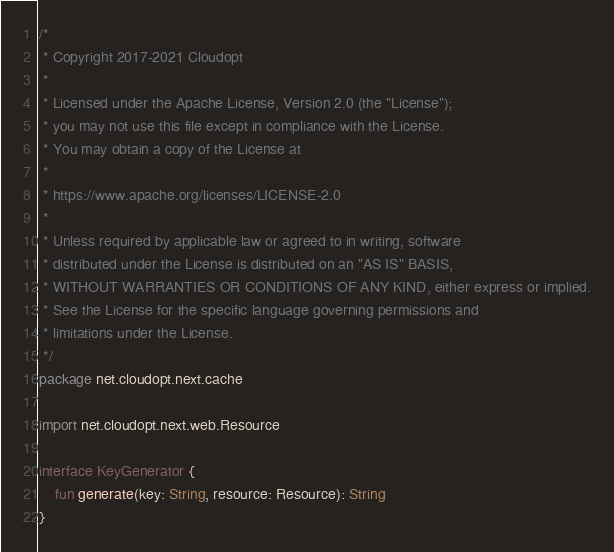Convert code to text. <code><loc_0><loc_0><loc_500><loc_500><_Kotlin_>/*
 * Copyright 2017-2021 Cloudopt
 *
 * Licensed under the Apache License, Version 2.0 (the "License");
 * you may not use this file except in compliance with the License.
 * You may obtain a copy of the License at
 *
 * https://www.apache.org/licenses/LICENSE-2.0
 *
 * Unless required by applicable law or agreed to in writing, software
 * distributed under the License is distributed on an "AS IS" BASIS,
 * WITHOUT WARRANTIES OR CONDITIONS OF ANY KIND, either express or implied.
 * See the License for the specific language governing permissions and
 * limitations under the License.
 */
package net.cloudopt.next.cache

import net.cloudopt.next.web.Resource

interface KeyGenerator {
    fun generate(key: String, resource: Resource): String
}</code> 